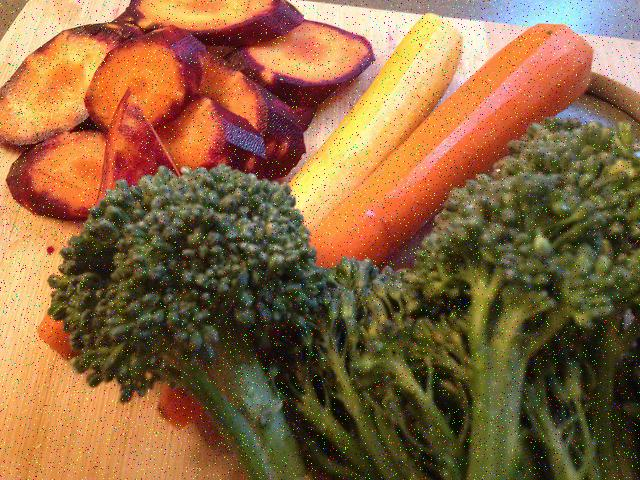What variety of vegetables can be seen in this image? The image presents a vibrant selection of vegetables, including what appears to be sliced red beets, a pair of whole carrots, and some fresh broccolis, all situated against a light-colored plate that contrasts well with the rich colors of the produce. 